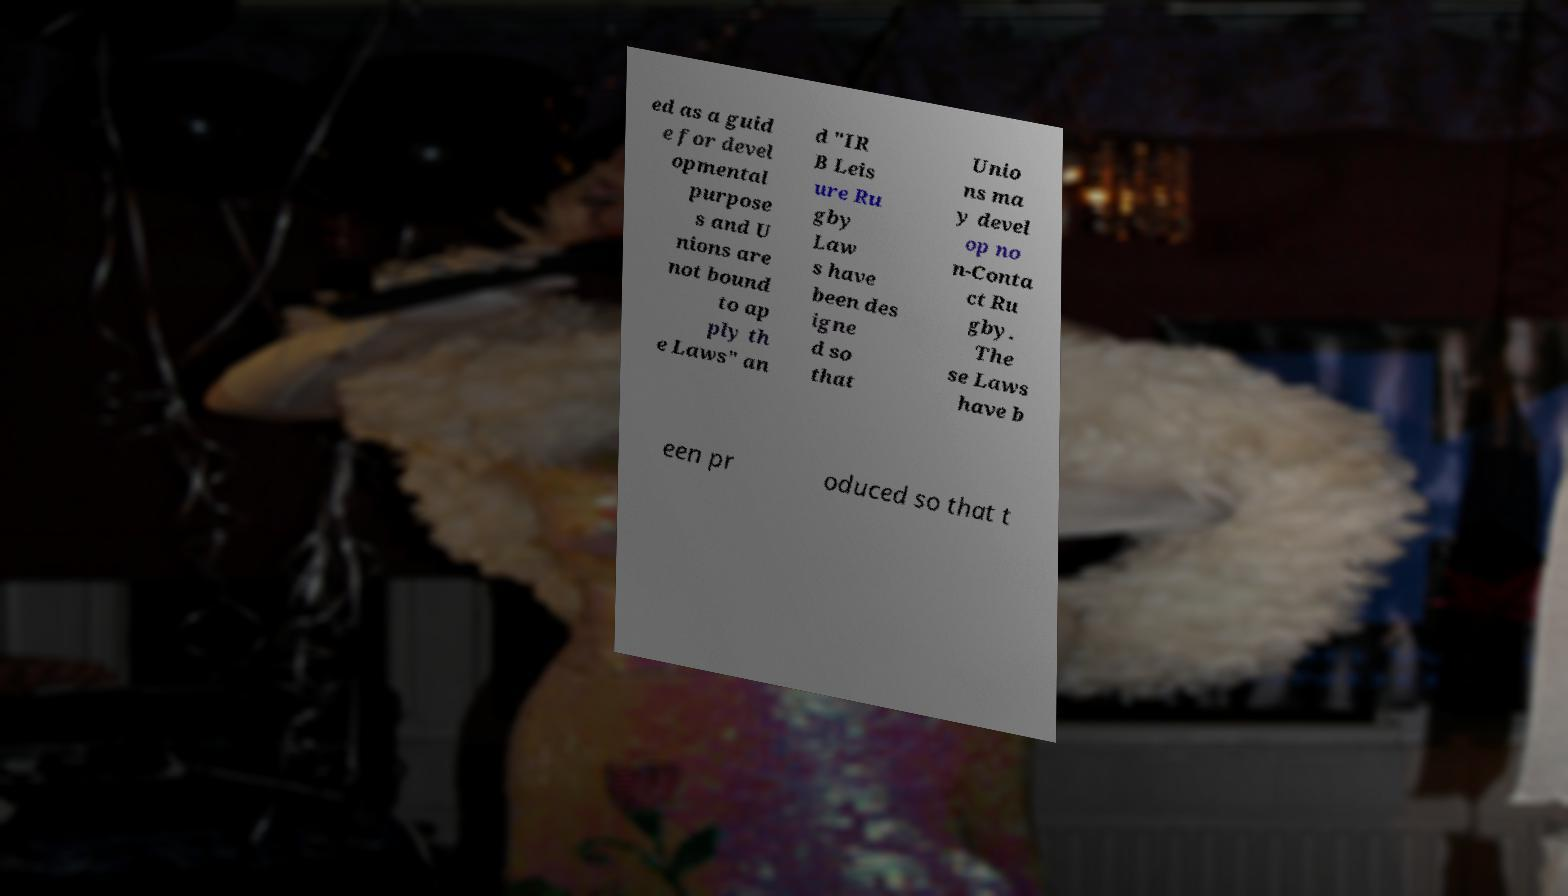Can you read and provide the text displayed in the image?This photo seems to have some interesting text. Can you extract and type it out for me? ed as a guid e for devel opmental purpose s and U nions are not bound to ap ply th e Laws" an d "IR B Leis ure Ru gby Law s have been des igne d so that Unio ns ma y devel op no n-Conta ct Ru gby. The se Laws have b een pr oduced so that t 